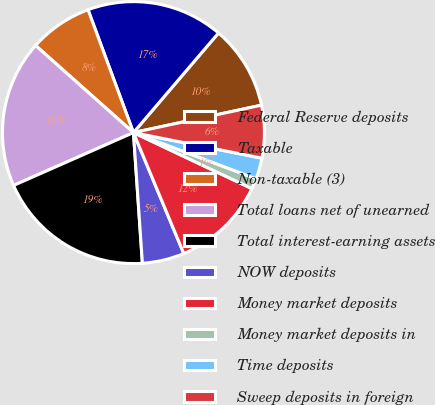Convert chart to OTSL. <chart><loc_0><loc_0><loc_500><loc_500><pie_chart><fcel>Federal Reserve deposits<fcel>Taxable<fcel>Non-taxable (3)<fcel>Total loans net of unearned<fcel>Total interest-earning assets<fcel>NOW deposits<fcel>Money market deposits<fcel>Money market deposits in<fcel>Time deposits<fcel>Sweep deposits in foreign<nl><fcel>10.39%<fcel>16.88%<fcel>7.79%<fcel>18.18%<fcel>19.48%<fcel>5.19%<fcel>11.69%<fcel>1.3%<fcel>2.6%<fcel>6.49%<nl></chart> 